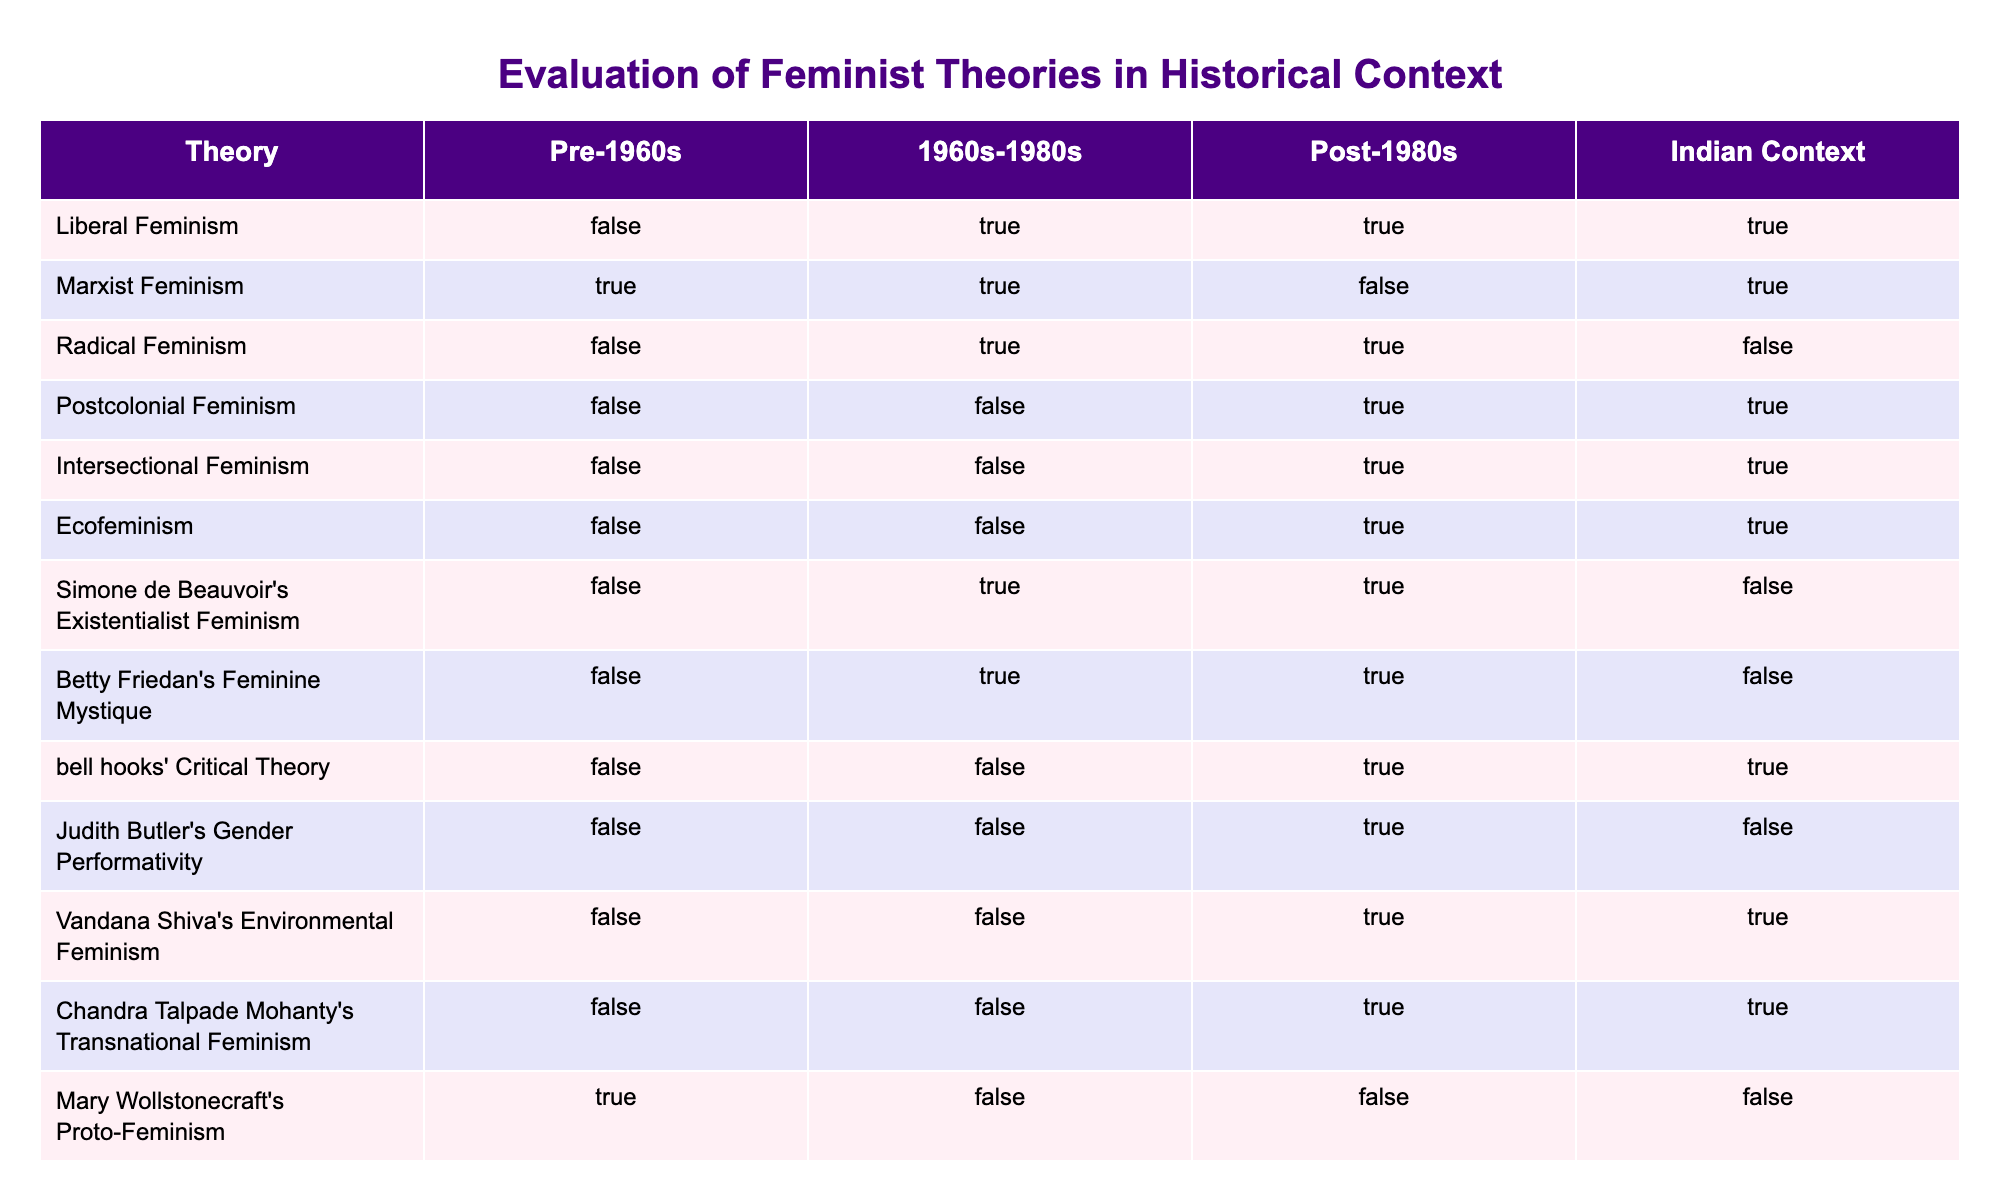What feminist theories were prevalent during the 1960s? According to the table, the theories that were marked as TRUE for the 1960s are Liberal Feminism, Marxist Feminism, Radical Feminism, and Virginia Woolf’s Room of One’s Own.
Answer: Liberal Feminism, Marxist Feminism, Radical Feminism, Virginia Woolf’s Room of One’s Own Which theories were not recognized in the post-1980s period? The theories marked as FALSE in the post-1980s section are Marxist Feminism, Radical Feminism, and Mary Wollstonecraft’s Proto-Feminism.
Answer: Marxist Feminism, Radical Feminism, Mary Wollstonecraft’s Proto-Feminism How many feminist theories were active in the Indian context? By counting the TRUE values in the Indian Context column, we find that there are six active theories: Liberal Feminism, Marxist Feminism, Postcolonial Feminism, Intersectional Feminism, bell hooks' Critical Theory, Vandana Shiva's Environmental Feminism, and Chandra Talpade Mohanty's Transnational Feminism.
Answer: Six Was there any feminist theory that remained inactive across all time periods? The table indicates that Mary Wollstonecraft's Proto-Feminism is marked as TRUE in the pre-1960s period but is marked FALSE in the subsequent periods, indicating it became inactive after that.
Answer: Yes Which theories changed from being active to inactive from the pre-1960s to post-1980s? In the table, we observe that Marxist Feminism started active (TRUE) before 1960 and shifted to inactive (FALSE) post-1980s, while Radical Feminism also transitioned from active to inactive.
Answer: Marxist Feminism, Radical Feminism What is the total count of theories that were consistently active from the 1960s onward? Evaluating the table, the theories that were marked as TRUE in both the 1960s and post-1980s are Liberal Feminism, Radical Feminism, and bell hooks' Critical Theory, totaling three theories.
Answer: Three Which feminist theory was only recognized in the post-1980s and not before? Based on the table, both Postcolonial Feminism and Intersectional Feminism are the theories that are marked as TRUE only in the post-1980s period, indicating their emergence after each earlier period.
Answer: Postcolonial Feminism, Intersectional Feminism How many theories are listed under Radical Feminism in the post-1980s column? The table shows that Radical Feminism is marked as TRUE in the 1960s and FALSE in the post-1980s column, indicating it was not recognized in that period. Therefore, there are zero theories listed under Radical Feminism in the post-1980s column.
Answer: Zero Which theory appears to have the widest temporal recognition based on the table? Liberal Feminism is marked as TRUE in both the 1960s and post-1980s, indicating it has the most extensive temporal recognition, alongside a TRUE value in the Indian context as well.
Answer: Liberal Feminism 